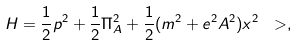<formula> <loc_0><loc_0><loc_500><loc_500>H = \frac { 1 } { 2 } p ^ { 2 } + \frac { 1 } { 2 } \Pi _ { A } ^ { 2 } + \frac { 1 } { 2 } ( m ^ { 2 } + e ^ { 2 } A ^ { 2 } ) x ^ { 2 } \ > ,</formula> 